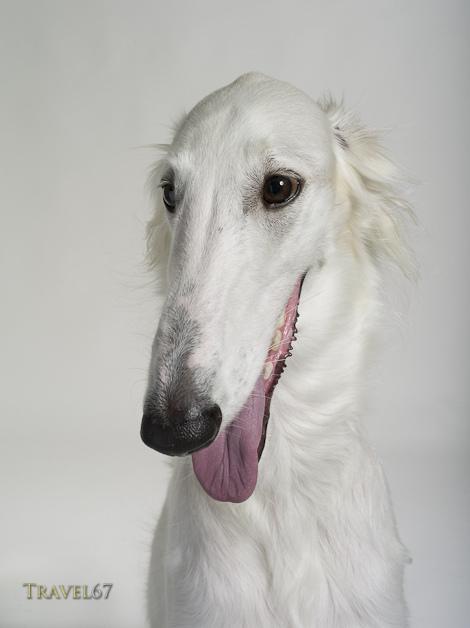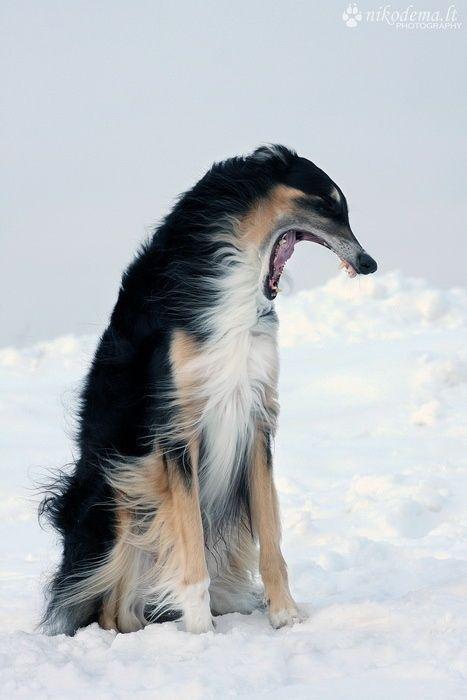The first image is the image on the left, the second image is the image on the right. Given the left and right images, does the statement "The dog in the image on the left is lying down." hold true? Answer yes or no. No. The first image is the image on the left, the second image is the image on the right. Assess this claim about the two images: "Both of the dogs are in similar body positions and with similar backgrounds.". Correct or not? Answer yes or no. Yes. 